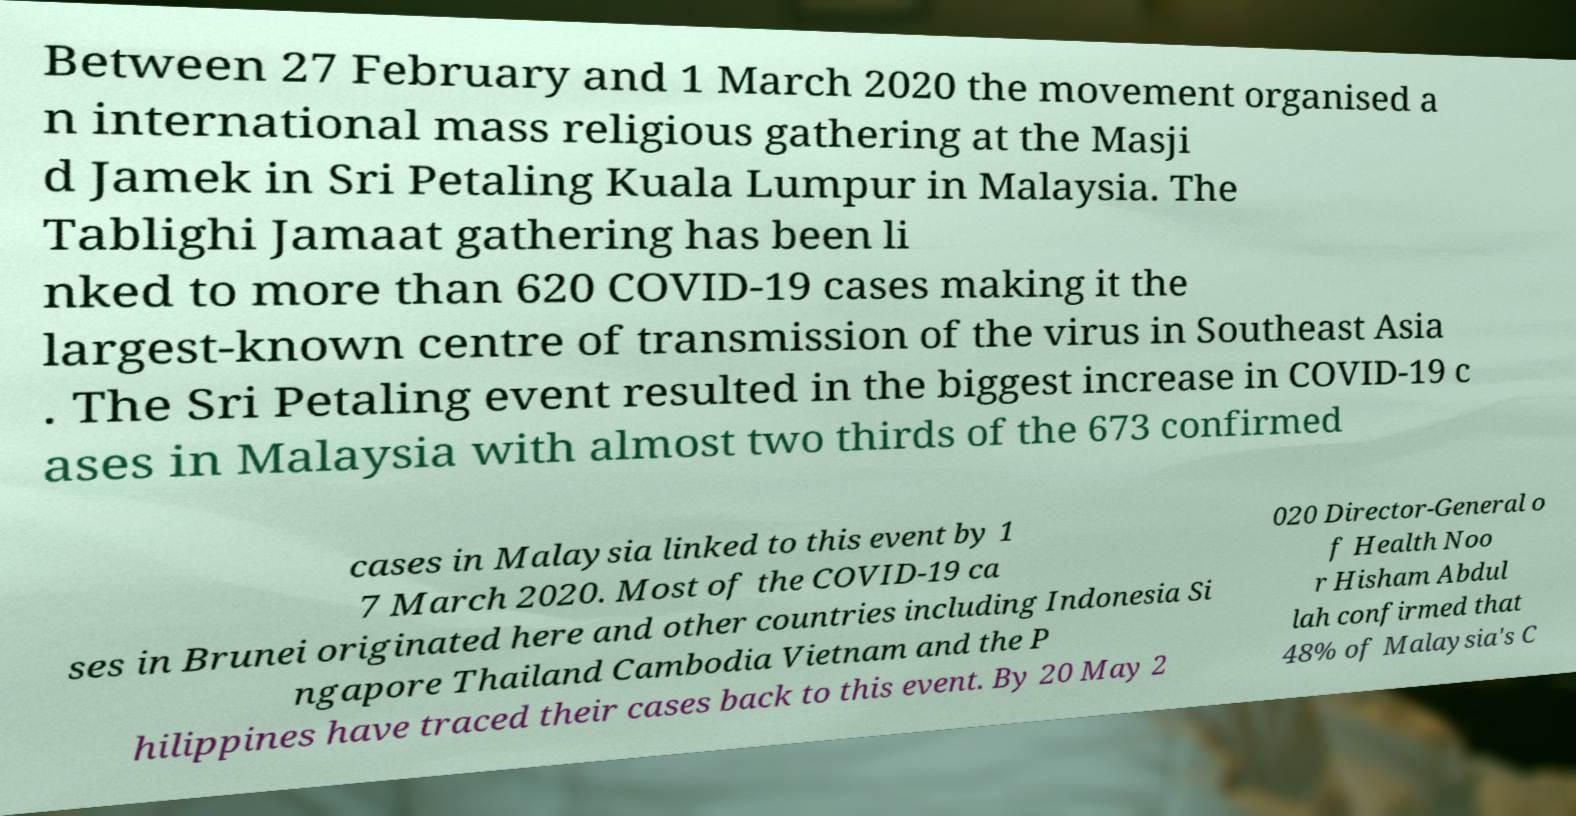Could you extract and type out the text from this image? Between 27 February and 1 March 2020 the movement organised a n international mass religious gathering at the Masji d Jamek in Sri Petaling Kuala Lumpur in Malaysia. The Tablighi Jamaat gathering has been li nked to more than 620 COVID-19 cases making it the largest-known centre of transmission of the virus in Southeast Asia . The Sri Petaling event resulted in the biggest increase in COVID-19 c ases in Malaysia with almost two thirds of the 673 confirmed cases in Malaysia linked to this event by 1 7 March 2020. Most of the COVID-19 ca ses in Brunei originated here and other countries including Indonesia Si ngapore Thailand Cambodia Vietnam and the P hilippines have traced their cases back to this event. By 20 May 2 020 Director-General o f Health Noo r Hisham Abdul lah confirmed that 48% of Malaysia's C 